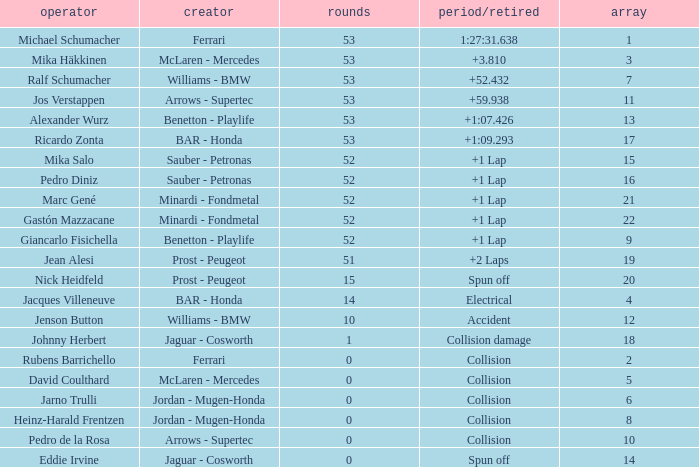What is the grid number with less than 52 laps and a Time/Retired of collision, and a Constructor of arrows - supertec? 1.0. 